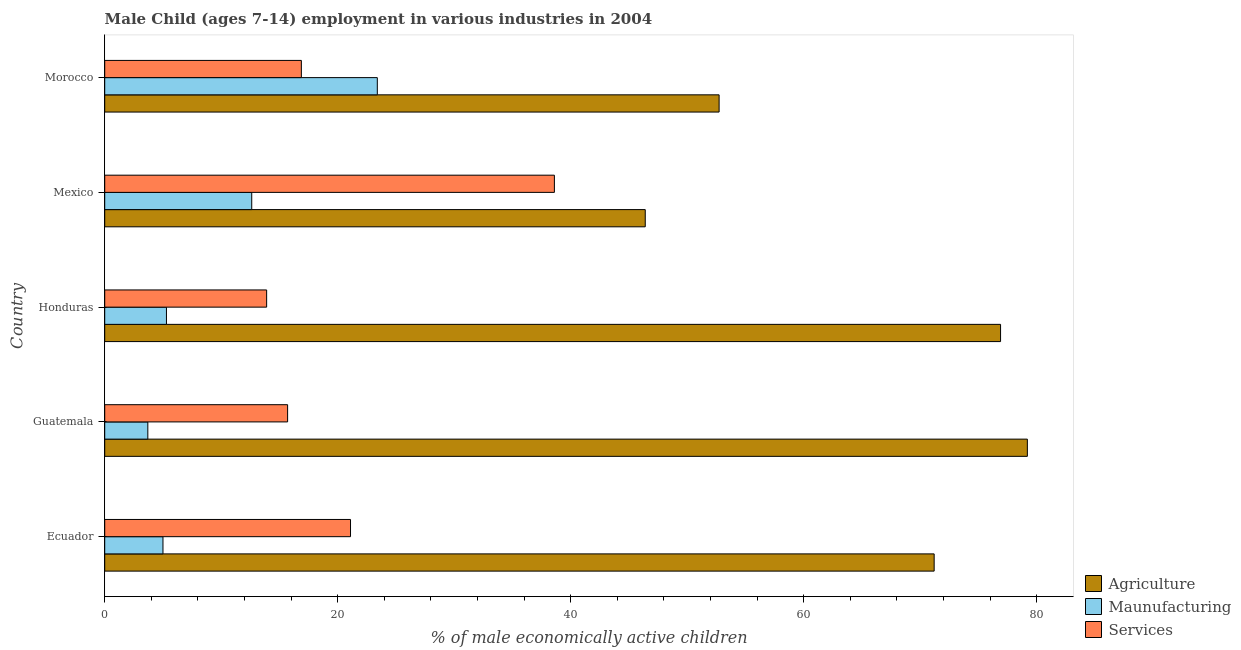How many bars are there on the 1st tick from the bottom?
Your answer should be very brief. 3. What is the label of the 4th group of bars from the top?
Your answer should be very brief. Guatemala. In how many cases, is the number of bars for a given country not equal to the number of legend labels?
Provide a short and direct response. 0. Across all countries, what is the maximum percentage of economically active children in services?
Offer a terse response. 38.6. Across all countries, what is the minimum percentage of economically active children in manufacturing?
Your answer should be compact. 3.7. In which country was the percentage of economically active children in manufacturing maximum?
Offer a terse response. Morocco. In which country was the percentage of economically active children in agriculture minimum?
Keep it short and to the point. Mexico. What is the total percentage of economically active children in services in the graph?
Make the answer very short. 106.18. What is the difference between the percentage of economically active children in agriculture in Ecuador and the percentage of economically active children in manufacturing in Honduras?
Your response must be concise. 65.9. What is the average percentage of economically active children in manufacturing per country?
Ensure brevity in your answer.  10. What is the difference between the percentage of economically active children in services and percentage of economically active children in agriculture in Guatemala?
Your answer should be compact. -63.5. In how many countries, is the percentage of economically active children in agriculture greater than 8 %?
Give a very brief answer. 5. What is the ratio of the percentage of economically active children in manufacturing in Guatemala to that in Morocco?
Your answer should be compact. 0.16. Is the percentage of economically active children in agriculture in Ecuador less than that in Guatemala?
Your answer should be compact. Yes. What is the difference between the highest and the second highest percentage of economically active children in services?
Provide a succinct answer. 17.5. Is the sum of the percentage of economically active children in services in Ecuador and Honduras greater than the maximum percentage of economically active children in agriculture across all countries?
Offer a terse response. No. What does the 2nd bar from the top in Ecuador represents?
Ensure brevity in your answer.  Maunufacturing. What does the 2nd bar from the bottom in Honduras represents?
Make the answer very short. Maunufacturing. Is it the case that in every country, the sum of the percentage of economically active children in agriculture and percentage of economically active children in manufacturing is greater than the percentage of economically active children in services?
Offer a terse response. Yes. How many bars are there?
Your answer should be compact. 15. Are all the bars in the graph horizontal?
Give a very brief answer. Yes. How many countries are there in the graph?
Your answer should be compact. 5. Are the values on the major ticks of X-axis written in scientific E-notation?
Offer a very short reply. No. What is the title of the graph?
Provide a succinct answer. Male Child (ages 7-14) employment in various industries in 2004. Does "Grants" appear as one of the legend labels in the graph?
Offer a terse response. No. What is the label or title of the X-axis?
Provide a succinct answer. % of male economically active children. What is the % of male economically active children of Agriculture in Ecuador?
Offer a terse response. 71.2. What is the % of male economically active children in Services in Ecuador?
Offer a terse response. 21.1. What is the % of male economically active children in Agriculture in Guatemala?
Keep it short and to the point. 79.2. What is the % of male economically active children in Maunufacturing in Guatemala?
Make the answer very short. 3.7. What is the % of male economically active children of Services in Guatemala?
Your response must be concise. 15.7. What is the % of male economically active children of Agriculture in Honduras?
Give a very brief answer. 76.9. What is the % of male economically active children of Maunufacturing in Honduras?
Ensure brevity in your answer.  5.3. What is the % of male economically active children of Services in Honduras?
Provide a succinct answer. 13.9. What is the % of male economically active children of Agriculture in Mexico?
Make the answer very short. 46.4. What is the % of male economically active children in Maunufacturing in Mexico?
Your answer should be compact. 12.62. What is the % of male economically active children of Services in Mexico?
Provide a succinct answer. 38.6. What is the % of male economically active children of Agriculture in Morocco?
Your answer should be compact. 52.74. What is the % of male economically active children of Maunufacturing in Morocco?
Your answer should be compact. 23.4. What is the % of male economically active children in Services in Morocco?
Keep it short and to the point. 16.88. Across all countries, what is the maximum % of male economically active children in Agriculture?
Offer a very short reply. 79.2. Across all countries, what is the maximum % of male economically active children in Maunufacturing?
Provide a short and direct response. 23.4. Across all countries, what is the maximum % of male economically active children in Services?
Offer a very short reply. 38.6. Across all countries, what is the minimum % of male economically active children of Agriculture?
Provide a succinct answer. 46.4. Across all countries, what is the minimum % of male economically active children in Maunufacturing?
Keep it short and to the point. 3.7. Across all countries, what is the minimum % of male economically active children of Services?
Offer a terse response. 13.9. What is the total % of male economically active children of Agriculture in the graph?
Make the answer very short. 326.44. What is the total % of male economically active children in Maunufacturing in the graph?
Your answer should be very brief. 50.02. What is the total % of male economically active children of Services in the graph?
Your answer should be very brief. 106.18. What is the difference between the % of male economically active children in Maunufacturing in Ecuador and that in Guatemala?
Your answer should be very brief. 1.3. What is the difference between the % of male economically active children in Agriculture in Ecuador and that in Honduras?
Keep it short and to the point. -5.7. What is the difference between the % of male economically active children of Maunufacturing in Ecuador and that in Honduras?
Your answer should be compact. -0.3. What is the difference between the % of male economically active children of Services in Ecuador and that in Honduras?
Provide a short and direct response. 7.2. What is the difference between the % of male economically active children of Agriculture in Ecuador and that in Mexico?
Provide a succinct answer. 24.8. What is the difference between the % of male economically active children of Maunufacturing in Ecuador and that in Mexico?
Keep it short and to the point. -7.62. What is the difference between the % of male economically active children of Services in Ecuador and that in Mexico?
Provide a succinct answer. -17.5. What is the difference between the % of male economically active children of Agriculture in Ecuador and that in Morocco?
Make the answer very short. 18.46. What is the difference between the % of male economically active children of Maunufacturing in Ecuador and that in Morocco?
Keep it short and to the point. -18.4. What is the difference between the % of male economically active children in Services in Ecuador and that in Morocco?
Your answer should be very brief. 4.22. What is the difference between the % of male economically active children in Agriculture in Guatemala and that in Honduras?
Ensure brevity in your answer.  2.3. What is the difference between the % of male economically active children of Maunufacturing in Guatemala and that in Honduras?
Ensure brevity in your answer.  -1.6. What is the difference between the % of male economically active children of Agriculture in Guatemala and that in Mexico?
Provide a succinct answer. 32.8. What is the difference between the % of male economically active children in Maunufacturing in Guatemala and that in Mexico?
Offer a terse response. -8.92. What is the difference between the % of male economically active children in Services in Guatemala and that in Mexico?
Your response must be concise. -22.9. What is the difference between the % of male economically active children in Agriculture in Guatemala and that in Morocco?
Keep it short and to the point. 26.46. What is the difference between the % of male economically active children in Maunufacturing in Guatemala and that in Morocco?
Your response must be concise. -19.7. What is the difference between the % of male economically active children of Services in Guatemala and that in Morocco?
Your answer should be compact. -1.18. What is the difference between the % of male economically active children in Agriculture in Honduras and that in Mexico?
Your answer should be very brief. 30.5. What is the difference between the % of male economically active children of Maunufacturing in Honduras and that in Mexico?
Keep it short and to the point. -7.32. What is the difference between the % of male economically active children in Services in Honduras and that in Mexico?
Make the answer very short. -24.7. What is the difference between the % of male economically active children in Agriculture in Honduras and that in Morocco?
Give a very brief answer. 24.16. What is the difference between the % of male economically active children of Maunufacturing in Honduras and that in Morocco?
Offer a terse response. -18.1. What is the difference between the % of male economically active children in Services in Honduras and that in Morocco?
Keep it short and to the point. -2.98. What is the difference between the % of male economically active children in Agriculture in Mexico and that in Morocco?
Keep it short and to the point. -6.34. What is the difference between the % of male economically active children in Maunufacturing in Mexico and that in Morocco?
Offer a very short reply. -10.78. What is the difference between the % of male economically active children of Services in Mexico and that in Morocco?
Provide a short and direct response. 21.72. What is the difference between the % of male economically active children in Agriculture in Ecuador and the % of male economically active children in Maunufacturing in Guatemala?
Provide a succinct answer. 67.5. What is the difference between the % of male economically active children in Agriculture in Ecuador and the % of male economically active children in Services in Guatemala?
Give a very brief answer. 55.5. What is the difference between the % of male economically active children in Agriculture in Ecuador and the % of male economically active children in Maunufacturing in Honduras?
Ensure brevity in your answer.  65.9. What is the difference between the % of male economically active children of Agriculture in Ecuador and the % of male economically active children of Services in Honduras?
Your answer should be very brief. 57.3. What is the difference between the % of male economically active children of Maunufacturing in Ecuador and the % of male economically active children of Services in Honduras?
Offer a terse response. -8.9. What is the difference between the % of male economically active children of Agriculture in Ecuador and the % of male economically active children of Maunufacturing in Mexico?
Give a very brief answer. 58.58. What is the difference between the % of male economically active children in Agriculture in Ecuador and the % of male economically active children in Services in Mexico?
Provide a succinct answer. 32.6. What is the difference between the % of male economically active children in Maunufacturing in Ecuador and the % of male economically active children in Services in Mexico?
Offer a very short reply. -33.6. What is the difference between the % of male economically active children in Agriculture in Ecuador and the % of male economically active children in Maunufacturing in Morocco?
Give a very brief answer. 47.8. What is the difference between the % of male economically active children of Agriculture in Ecuador and the % of male economically active children of Services in Morocco?
Your answer should be compact. 54.32. What is the difference between the % of male economically active children of Maunufacturing in Ecuador and the % of male economically active children of Services in Morocco?
Keep it short and to the point. -11.88. What is the difference between the % of male economically active children of Agriculture in Guatemala and the % of male economically active children of Maunufacturing in Honduras?
Give a very brief answer. 73.9. What is the difference between the % of male economically active children in Agriculture in Guatemala and the % of male economically active children in Services in Honduras?
Provide a succinct answer. 65.3. What is the difference between the % of male economically active children in Agriculture in Guatemala and the % of male economically active children in Maunufacturing in Mexico?
Provide a short and direct response. 66.58. What is the difference between the % of male economically active children of Agriculture in Guatemala and the % of male economically active children of Services in Mexico?
Make the answer very short. 40.6. What is the difference between the % of male economically active children of Maunufacturing in Guatemala and the % of male economically active children of Services in Mexico?
Offer a very short reply. -34.9. What is the difference between the % of male economically active children in Agriculture in Guatemala and the % of male economically active children in Maunufacturing in Morocco?
Make the answer very short. 55.8. What is the difference between the % of male economically active children in Agriculture in Guatemala and the % of male economically active children in Services in Morocco?
Offer a terse response. 62.32. What is the difference between the % of male economically active children in Maunufacturing in Guatemala and the % of male economically active children in Services in Morocco?
Provide a short and direct response. -13.18. What is the difference between the % of male economically active children of Agriculture in Honduras and the % of male economically active children of Maunufacturing in Mexico?
Your answer should be very brief. 64.28. What is the difference between the % of male economically active children in Agriculture in Honduras and the % of male economically active children in Services in Mexico?
Provide a short and direct response. 38.3. What is the difference between the % of male economically active children in Maunufacturing in Honduras and the % of male economically active children in Services in Mexico?
Your answer should be compact. -33.3. What is the difference between the % of male economically active children of Agriculture in Honduras and the % of male economically active children of Maunufacturing in Morocco?
Give a very brief answer. 53.5. What is the difference between the % of male economically active children in Agriculture in Honduras and the % of male economically active children in Services in Morocco?
Ensure brevity in your answer.  60.02. What is the difference between the % of male economically active children of Maunufacturing in Honduras and the % of male economically active children of Services in Morocco?
Make the answer very short. -11.58. What is the difference between the % of male economically active children of Agriculture in Mexico and the % of male economically active children of Maunufacturing in Morocco?
Provide a short and direct response. 23. What is the difference between the % of male economically active children of Agriculture in Mexico and the % of male economically active children of Services in Morocco?
Your answer should be very brief. 29.52. What is the difference between the % of male economically active children in Maunufacturing in Mexico and the % of male economically active children in Services in Morocco?
Keep it short and to the point. -4.26. What is the average % of male economically active children of Agriculture per country?
Your answer should be compact. 65.29. What is the average % of male economically active children of Maunufacturing per country?
Your answer should be very brief. 10. What is the average % of male economically active children in Services per country?
Offer a terse response. 21.24. What is the difference between the % of male economically active children of Agriculture and % of male economically active children of Maunufacturing in Ecuador?
Keep it short and to the point. 66.2. What is the difference between the % of male economically active children of Agriculture and % of male economically active children of Services in Ecuador?
Ensure brevity in your answer.  50.1. What is the difference between the % of male economically active children of Maunufacturing and % of male economically active children of Services in Ecuador?
Give a very brief answer. -16.1. What is the difference between the % of male economically active children of Agriculture and % of male economically active children of Maunufacturing in Guatemala?
Keep it short and to the point. 75.5. What is the difference between the % of male economically active children in Agriculture and % of male economically active children in Services in Guatemala?
Provide a short and direct response. 63.5. What is the difference between the % of male economically active children of Agriculture and % of male economically active children of Maunufacturing in Honduras?
Keep it short and to the point. 71.6. What is the difference between the % of male economically active children of Agriculture and % of male economically active children of Services in Honduras?
Provide a succinct answer. 63. What is the difference between the % of male economically active children of Agriculture and % of male economically active children of Maunufacturing in Mexico?
Give a very brief answer. 33.78. What is the difference between the % of male economically active children of Maunufacturing and % of male economically active children of Services in Mexico?
Make the answer very short. -25.98. What is the difference between the % of male economically active children of Agriculture and % of male economically active children of Maunufacturing in Morocco?
Provide a succinct answer. 29.34. What is the difference between the % of male economically active children of Agriculture and % of male economically active children of Services in Morocco?
Ensure brevity in your answer.  35.86. What is the difference between the % of male economically active children of Maunufacturing and % of male economically active children of Services in Morocco?
Make the answer very short. 6.52. What is the ratio of the % of male economically active children in Agriculture in Ecuador to that in Guatemala?
Make the answer very short. 0.9. What is the ratio of the % of male economically active children of Maunufacturing in Ecuador to that in Guatemala?
Ensure brevity in your answer.  1.35. What is the ratio of the % of male economically active children in Services in Ecuador to that in Guatemala?
Provide a succinct answer. 1.34. What is the ratio of the % of male economically active children in Agriculture in Ecuador to that in Honduras?
Offer a terse response. 0.93. What is the ratio of the % of male economically active children in Maunufacturing in Ecuador to that in Honduras?
Offer a very short reply. 0.94. What is the ratio of the % of male economically active children of Services in Ecuador to that in Honduras?
Offer a terse response. 1.52. What is the ratio of the % of male economically active children of Agriculture in Ecuador to that in Mexico?
Keep it short and to the point. 1.53. What is the ratio of the % of male economically active children in Maunufacturing in Ecuador to that in Mexico?
Provide a short and direct response. 0.4. What is the ratio of the % of male economically active children of Services in Ecuador to that in Mexico?
Make the answer very short. 0.55. What is the ratio of the % of male economically active children of Agriculture in Ecuador to that in Morocco?
Keep it short and to the point. 1.35. What is the ratio of the % of male economically active children of Maunufacturing in Ecuador to that in Morocco?
Provide a short and direct response. 0.21. What is the ratio of the % of male economically active children of Services in Ecuador to that in Morocco?
Make the answer very short. 1.25. What is the ratio of the % of male economically active children of Agriculture in Guatemala to that in Honduras?
Your answer should be compact. 1.03. What is the ratio of the % of male economically active children in Maunufacturing in Guatemala to that in Honduras?
Keep it short and to the point. 0.7. What is the ratio of the % of male economically active children of Services in Guatemala to that in Honduras?
Provide a short and direct response. 1.13. What is the ratio of the % of male economically active children of Agriculture in Guatemala to that in Mexico?
Give a very brief answer. 1.71. What is the ratio of the % of male economically active children of Maunufacturing in Guatemala to that in Mexico?
Keep it short and to the point. 0.29. What is the ratio of the % of male economically active children in Services in Guatemala to that in Mexico?
Make the answer very short. 0.41. What is the ratio of the % of male economically active children of Agriculture in Guatemala to that in Morocco?
Your answer should be very brief. 1.5. What is the ratio of the % of male economically active children in Maunufacturing in Guatemala to that in Morocco?
Keep it short and to the point. 0.16. What is the ratio of the % of male economically active children in Services in Guatemala to that in Morocco?
Keep it short and to the point. 0.93. What is the ratio of the % of male economically active children in Agriculture in Honduras to that in Mexico?
Your answer should be compact. 1.66. What is the ratio of the % of male economically active children in Maunufacturing in Honduras to that in Mexico?
Your answer should be very brief. 0.42. What is the ratio of the % of male economically active children of Services in Honduras to that in Mexico?
Your response must be concise. 0.36. What is the ratio of the % of male economically active children in Agriculture in Honduras to that in Morocco?
Your answer should be compact. 1.46. What is the ratio of the % of male economically active children of Maunufacturing in Honduras to that in Morocco?
Your answer should be very brief. 0.23. What is the ratio of the % of male economically active children in Services in Honduras to that in Morocco?
Keep it short and to the point. 0.82. What is the ratio of the % of male economically active children of Agriculture in Mexico to that in Morocco?
Offer a terse response. 0.88. What is the ratio of the % of male economically active children of Maunufacturing in Mexico to that in Morocco?
Keep it short and to the point. 0.54. What is the ratio of the % of male economically active children of Services in Mexico to that in Morocco?
Offer a very short reply. 2.29. What is the difference between the highest and the second highest % of male economically active children of Agriculture?
Provide a succinct answer. 2.3. What is the difference between the highest and the second highest % of male economically active children of Maunufacturing?
Your response must be concise. 10.78. What is the difference between the highest and the second highest % of male economically active children of Services?
Offer a terse response. 17.5. What is the difference between the highest and the lowest % of male economically active children in Agriculture?
Provide a succinct answer. 32.8. What is the difference between the highest and the lowest % of male economically active children in Maunufacturing?
Provide a short and direct response. 19.7. What is the difference between the highest and the lowest % of male economically active children in Services?
Offer a very short reply. 24.7. 